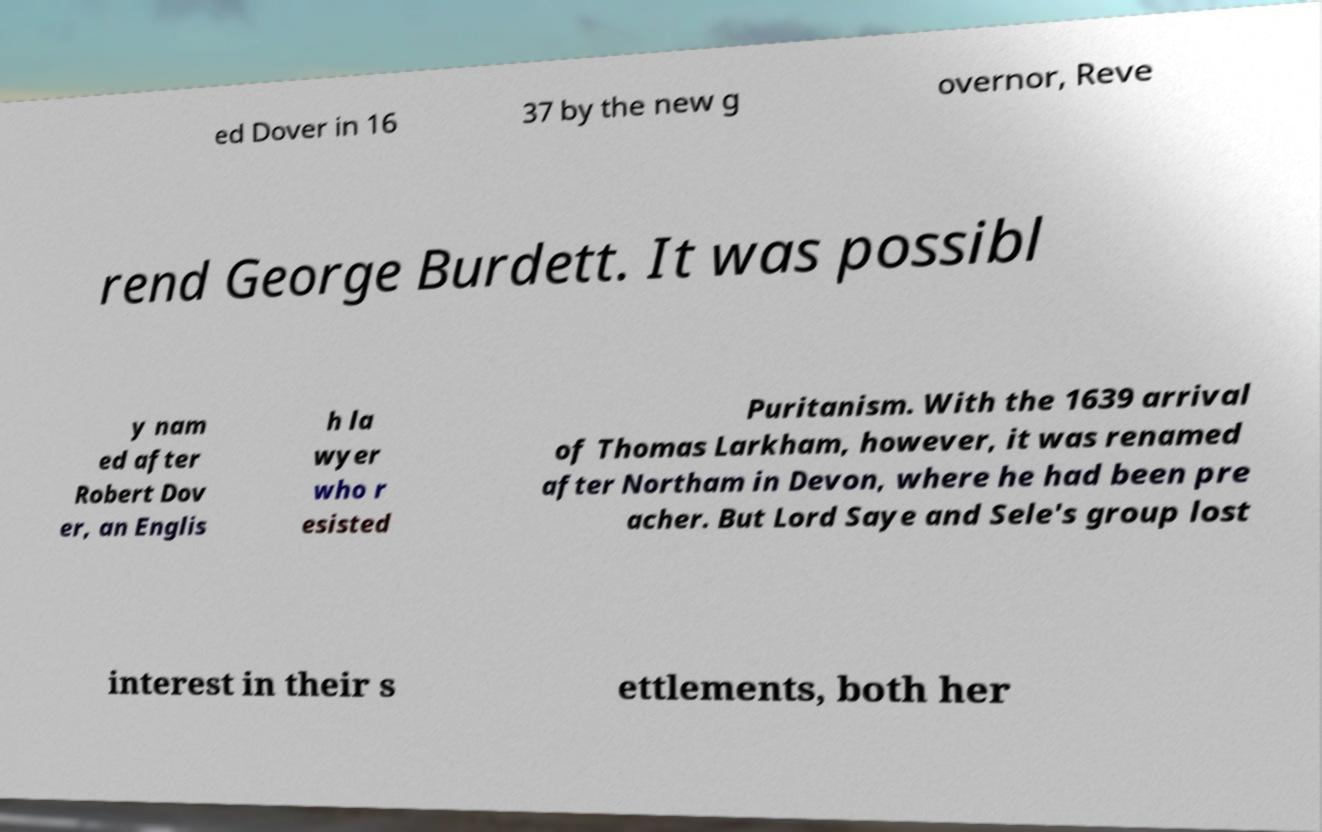What messages or text are displayed in this image? I need them in a readable, typed format. ed Dover in 16 37 by the new g overnor, Reve rend George Burdett. It was possibl y nam ed after Robert Dov er, an Englis h la wyer who r esisted Puritanism. With the 1639 arrival of Thomas Larkham, however, it was renamed after Northam in Devon, where he had been pre acher. But Lord Saye and Sele's group lost interest in their s ettlements, both her 